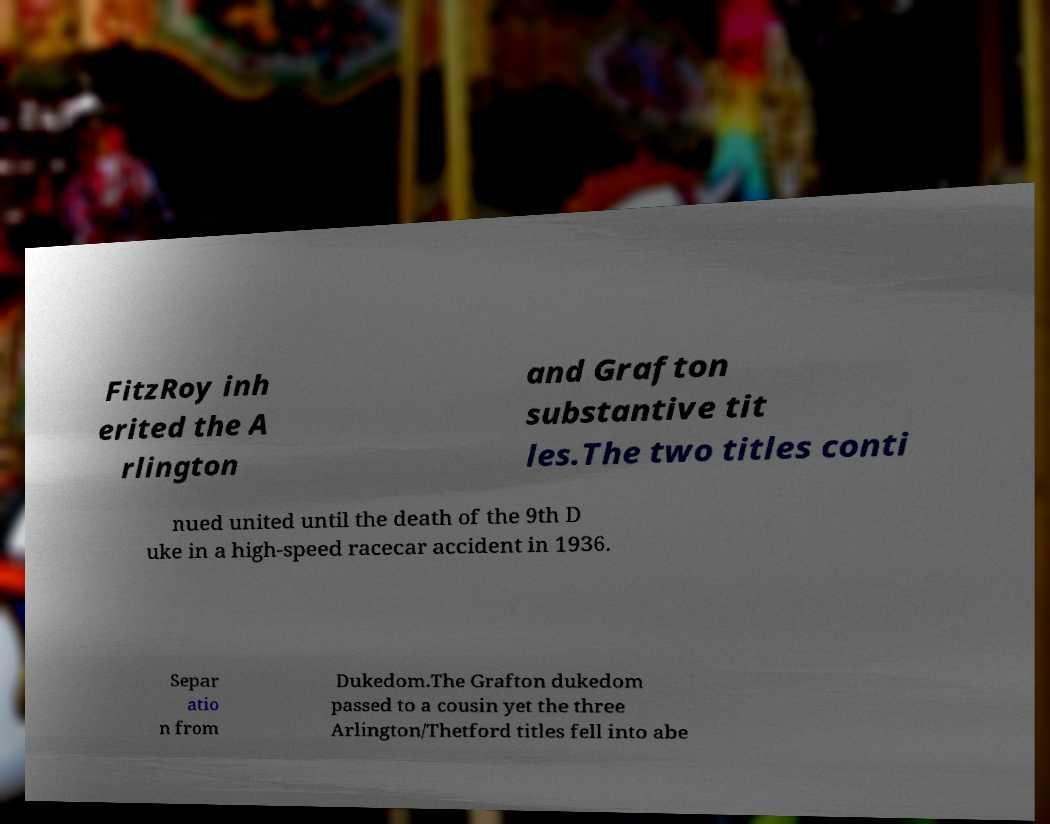I need the written content from this picture converted into text. Can you do that? FitzRoy inh erited the A rlington and Grafton substantive tit les.The two titles conti nued united until the death of the 9th D uke in a high-speed racecar accident in 1936. Separ atio n from Dukedom.The Grafton dukedom passed to a cousin yet the three Arlington/Thetford titles fell into abe 